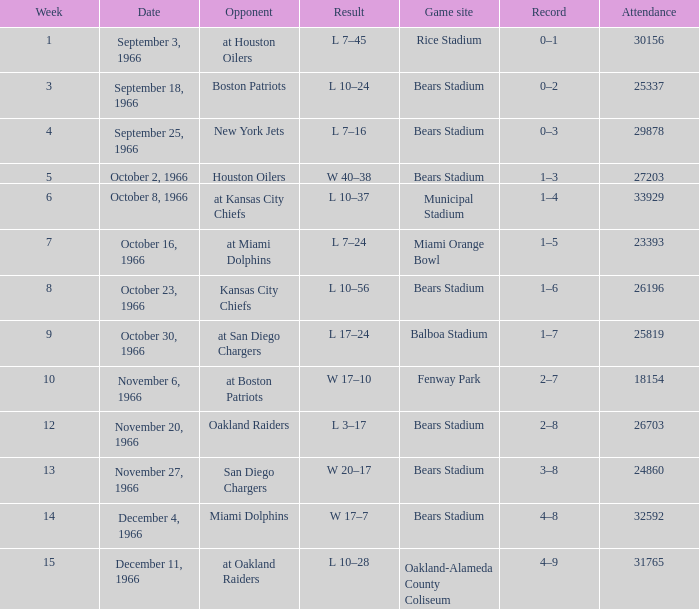On October 16, 1966, what was the game site? Miami Orange Bowl. 